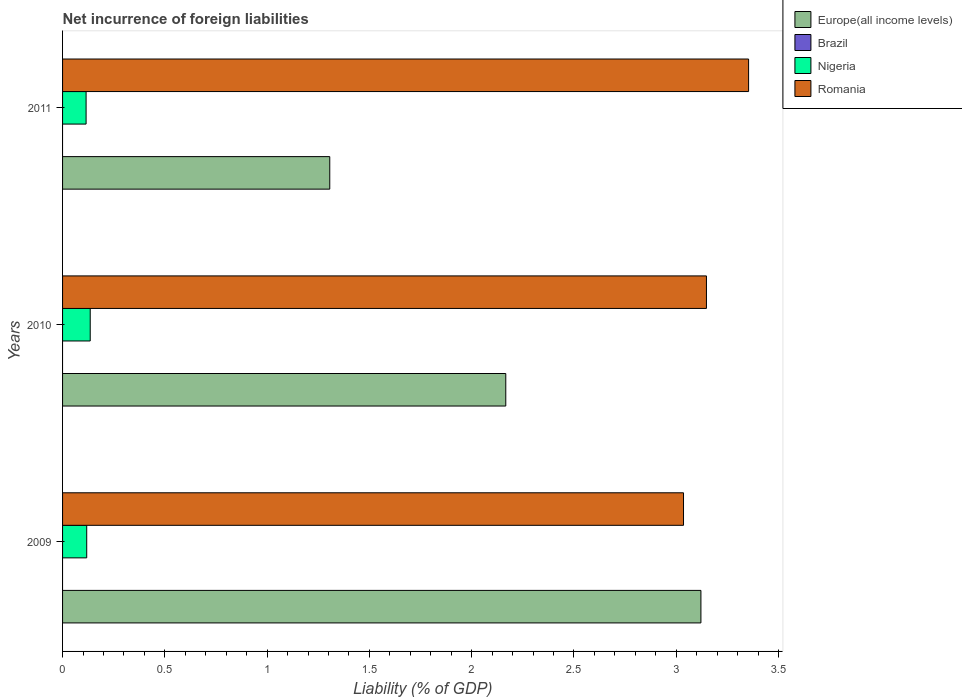How many different coloured bars are there?
Your answer should be very brief. 3. Are the number of bars per tick equal to the number of legend labels?
Provide a short and direct response. No. What is the net incurrence of foreign liabilities in Romania in 2010?
Your response must be concise. 3.15. Across all years, what is the maximum net incurrence of foreign liabilities in Europe(all income levels)?
Your answer should be compact. 3.12. In which year was the net incurrence of foreign liabilities in Europe(all income levels) maximum?
Make the answer very short. 2009. What is the total net incurrence of foreign liabilities in Romania in the graph?
Your response must be concise. 9.54. What is the difference between the net incurrence of foreign liabilities in Nigeria in 2009 and that in 2010?
Your answer should be compact. -0.02. What is the difference between the net incurrence of foreign liabilities in Brazil in 2010 and the net incurrence of foreign liabilities in Romania in 2009?
Your response must be concise. -3.04. What is the average net incurrence of foreign liabilities in Europe(all income levels) per year?
Keep it short and to the point. 2.2. In the year 2010, what is the difference between the net incurrence of foreign liabilities in Europe(all income levels) and net incurrence of foreign liabilities in Romania?
Keep it short and to the point. -0.98. In how many years, is the net incurrence of foreign liabilities in Romania greater than 1.7 %?
Your response must be concise. 3. What is the ratio of the net incurrence of foreign liabilities in Europe(all income levels) in 2009 to that in 2011?
Make the answer very short. 2.39. Is the net incurrence of foreign liabilities in Romania in 2009 less than that in 2011?
Give a very brief answer. Yes. Is the difference between the net incurrence of foreign liabilities in Europe(all income levels) in 2009 and 2010 greater than the difference between the net incurrence of foreign liabilities in Romania in 2009 and 2010?
Provide a short and direct response. Yes. What is the difference between the highest and the second highest net incurrence of foreign liabilities in Romania?
Your answer should be compact. 0.21. What is the difference between the highest and the lowest net incurrence of foreign liabilities in Nigeria?
Your answer should be compact. 0.02. Is it the case that in every year, the sum of the net incurrence of foreign liabilities in Brazil and net incurrence of foreign liabilities in Romania is greater than the sum of net incurrence of foreign liabilities in Nigeria and net incurrence of foreign liabilities in Europe(all income levels)?
Provide a succinct answer. No. Are all the bars in the graph horizontal?
Provide a short and direct response. Yes. Does the graph contain any zero values?
Keep it short and to the point. Yes. Does the graph contain grids?
Provide a short and direct response. No. Where does the legend appear in the graph?
Offer a terse response. Top right. What is the title of the graph?
Provide a short and direct response. Net incurrence of foreign liabilities. What is the label or title of the X-axis?
Ensure brevity in your answer.  Liability (% of GDP). What is the label or title of the Y-axis?
Offer a terse response. Years. What is the Liability (% of GDP) in Europe(all income levels) in 2009?
Give a very brief answer. 3.12. What is the Liability (% of GDP) of Brazil in 2009?
Give a very brief answer. 0. What is the Liability (% of GDP) of Nigeria in 2009?
Ensure brevity in your answer.  0.12. What is the Liability (% of GDP) of Romania in 2009?
Ensure brevity in your answer.  3.04. What is the Liability (% of GDP) in Europe(all income levels) in 2010?
Make the answer very short. 2.17. What is the Liability (% of GDP) of Nigeria in 2010?
Give a very brief answer. 0.14. What is the Liability (% of GDP) in Romania in 2010?
Your answer should be compact. 3.15. What is the Liability (% of GDP) of Europe(all income levels) in 2011?
Make the answer very short. 1.31. What is the Liability (% of GDP) in Nigeria in 2011?
Your answer should be very brief. 0.12. What is the Liability (% of GDP) in Romania in 2011?
Your response must be concise. 3.35. Across all years, what is the maximum Liability (% of GDP) in Europe(all income levels)?
Your answer should be very brief. 3.12. Across all years, what is the maximum Liability (% of GDP) in Nigeria?
Your answer should be compact. 0.14. Across all years, what is the maximum Liability (% of GDP) of Romania?
Provide a short and direct response. 3.35. Across all years, what is the minimum Liability (% of GDP) in Europe(all income levels)?
Your response must be concise. 1.31. Across all years, what is the minimum Liability (% of GDP) in Nigeria?
Your answer should be very brief. 0.12. Across all years, what is the minimum Liability (% of GDP) in Romania?
Keep it short and to the point. 3.04. What is the total Liability (% of GDP) of Europe(all income levels) in the graph?
Offer a terse response. 6.59. What is the total Liability (% of GDP) of Brazil in the graph?
Your response must be concise. 0. What is the total Liability (% of GDP) of Nigeria in the graph?
Offer a terse response. 0.37. What is the total Liability (% of GDP) in Romania in the graph?
Give a very brief answer. 9.54. What is the difference between the Liability (% of GDP) in Europe(all income levels) in 2009 and that in 2010?
Offer a terse response. 0.95. What is the difference between the Liability (% of GDP) in Nigeria in 2009 and that in 2010?
Offer a terse response. -0.02. What is the difference between the Liability (% of GDP) in Romania in 2009 and that in 2010?
Make the answer very short. -0.11. What is the difference between the Liability (% of GDP) of Europe(all income levels) in 2009 and that in 2011?
Your answer should be compact. 1.81. What is the difference between the Liability (% of GDP) of Nigeria in 2009 and that in 2011?
Give a very brief answer. 0. What is the difference between the Liability (% of GDP) in Romania in 2009 and that in 2011?
Give a very brief answer. -0.32. What is the difference between the Liability (% of GDP) in Europe(all income levels) in 2010 and that in 2011?
Offer a very short reply. 0.86. What is the difference between the Liability (% of GDP) of Nigeria in 2010 and that in 2011?
Keep it short and to the point. 0.02. What is the difference between the Liability (% of GDP) in Romania in 2010 and that in 2011?
Give a very brief answer. -0.21. What is the difference between the Liability (% of GDP) in Europe(all income levels) in 2009 and the Liability (% of GDP) in Nigeria in 2010?
Offer a very short reply. 2.99. What is the difference between the Liability (% of GDP) in Europe(all income levels) in 2009 and the Liability (% of GDP) in Romania in 2010?
Provide a short and direct response. -0.03. What is the difference between the Liability (% of GDP) in Nigeria in 2009 and the Liability (% of GDP) in Romania in 2010?
Offer a very short reply. -3.03. What is the difference between the Liability (% of GDP) in Europe(all income levels) in 2009 and the Liability (% of GDP) in Nigeria in 2011?
Keep it short and to the point. 3.01. What is the difference between the Liability (% of GDP) of Europe(all income levels) in 2009 and the Liability (% of GDP) of Romania in 2011?
Give a very brief answer. -0.23. What is the difference between the Liability (% of GDP) of Nigeria in 2009 and the Liability (% of GDP) of Romania in 2011?
Ensure brevity in your answer.  -3.24. What is the difference between the Liability (% of GDP) in Europe(all income levels) in 2010 and the Liability (% of GDP) in Nigeria in 2011?
Provide a succinct answer. 2.05. What is the difference between the Liability (% of GDP) in Europe(all income levels) in 2010 and the Liability (% of GDP) in Romania in 2011?
Offer a terse response. -1.19. What is the difference between the Liability (% of GDP) of Nigeria in 2010 and the Liability (% of GDP) of Romania in 2011?
Offer a terse response. -3.22. What is the average Liability (% of GDP) in Europe(all income levels) per year?
Provide a succinct answer. 2.2. What is the average Liability (% of GDP) of Brazil per year?
Keep it short and to the point. 0. What is the average Liability (% of GDP) of Nigeria per year?
Make the answer very short. 0.12. What is the average Liability (% of GDP) of Romania per year?
Offer a terse response. 3.18. In the year 2009, what is the difference between the Liability (% of GDP) of Europe(all income levels) and Liability (% of GDP) of Nigeria?
Your answer should be compact. 3. In the year 2009, what is the difference between the Liability (% of GDP) in Europe(all income levels) and Liability (% of GDP) in Romania?
Provide a short and direct response. 0.09. In the year 2009, what is the difference between the Liability (% of GDP) in Nigeria and Liability (% of GDP) in Romania?
Your answer should be very brief. -2.92. In the year 2010, what is the difference between the Liability (% of GDP) in Europe(all income levels) and Liability (% of GDP) in Nigeria?
Offer a very short reply. 2.03. In the year 2010, what is the difference between the Liability (% of GDP) of Europe(all income levels) and Liability (% of GDP) of Romania?
Provide a succinct answer. -0.98. In the year 2010, what is the difference between the Liability (% of GDP) in Nigeria and Liability (% of GDP) in Romania?
Your answer should be very brief. -3.01. In the year 2011, what is the difference between the Liability (% of GDP) of Europe(all income levels) and Liability (% of GDP) of Nigeria?
Offer a very short reply. 1.19. In the year 2011, what is the difference between the Liability (% of GDP) of Europe(all income levels) and Liability (% of GDP) of Romania?
Keep it short and to the point. -2.05. In the year 2011, what is the difference between the Liability (% of GDP) of Nigeria and Liability (% of GDP) of Romania?
Offer a very short reply. -3.24. What is the ratio of the Liability (% of GDP) in Europe(all income levels) in 2009 to that in 2010?
Provide a succinct answer. 1.44. What is the ratio of the Liability (% of GDP) in Nigeria in 2009 to that in 2010?
Your answer should be compact. 0.87. What is the ratio of the Liability (% of GDP) of Romania in 2009 to that in 2010?
Provide a succinct answer. 0.96. What is the ratio of the Liability (% of GDP) in Europe(all income levels) in 2009 to that in 2011?
Offer a very short reply. 2.39. What is the ratio of the Liability (% of GDP) of Nigeria in 2009 to that in 2011?
Ensure brevity in your answer.  1.03. What is the ratio of the Liability (% of GDP) in Romania in 2009 to that in 2011?
Your response must be concise. 0.91. What is the ratio of the Liability (% of GDP) in Europe(all income levels) in 2010 to that in 2011?
Provide a succinct answer. 1.66. What is the ratio of the Liability (% of GDP) in Nigeria in 2010 to that in 2011?
Your answer should be very brief. 1.18. What is the ratio of the Liability (% of GDP) in Romania in 2010 to that in 2011?
Your answer should be very brief. 0.94. What is the difference between the highest and the second highest Liability (% of GDP) of Europe(all income levels)?
Your answer should be compact. 0.95. What is the difference between the highest and the second highest Liability (% of GDP) of Nigeria?
Provide a short and direct response. 0.02. What is the difference between the highest and the second highest Liability (% of GDP) of Romania?
Offer a very short reply. 0.21. What is the difference between the highest and the lowest Liability (% of GDP) of Europe(all income levels)?
Offer a very short reply. 1.81. What is the difference between the highest and the lowest Liability (% of GDP) in Nigeria?
Offer a very short reply. 0.02. What is the difference between the highest and the lowest Liability (% of GDP) in Romania?
Your answer should be very brief. 0.32. 